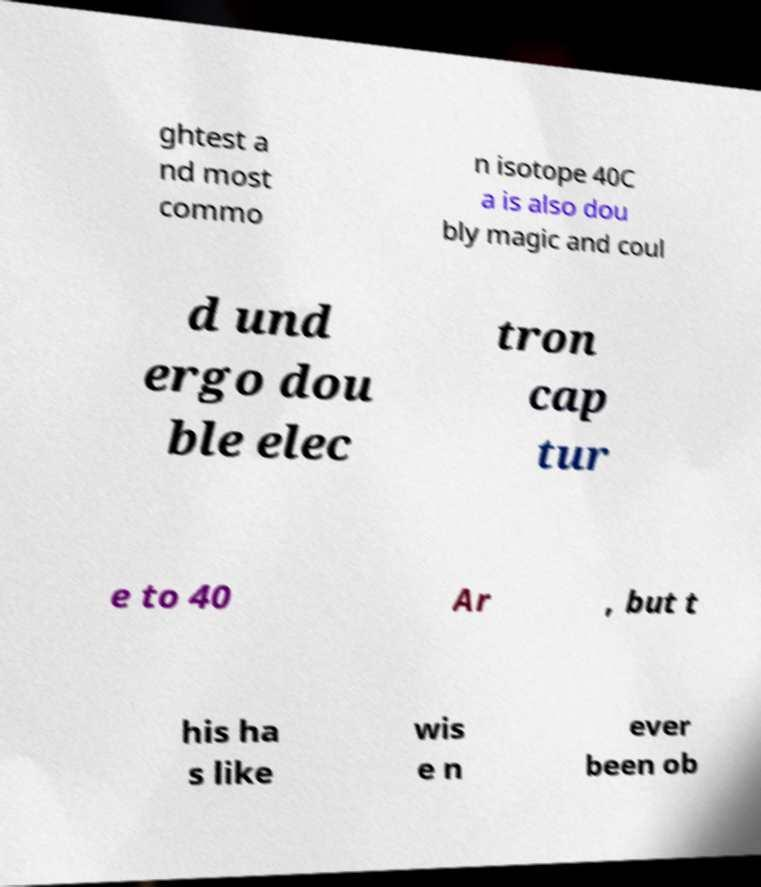Could you extract and type out the text from this image? ghtest a nd most commo n isotope 40C a is also dou bly magic and coul d und ergo dou ble elec tron cap tur e to 40 Ar , but t his ha s like wis e n ever been ob 